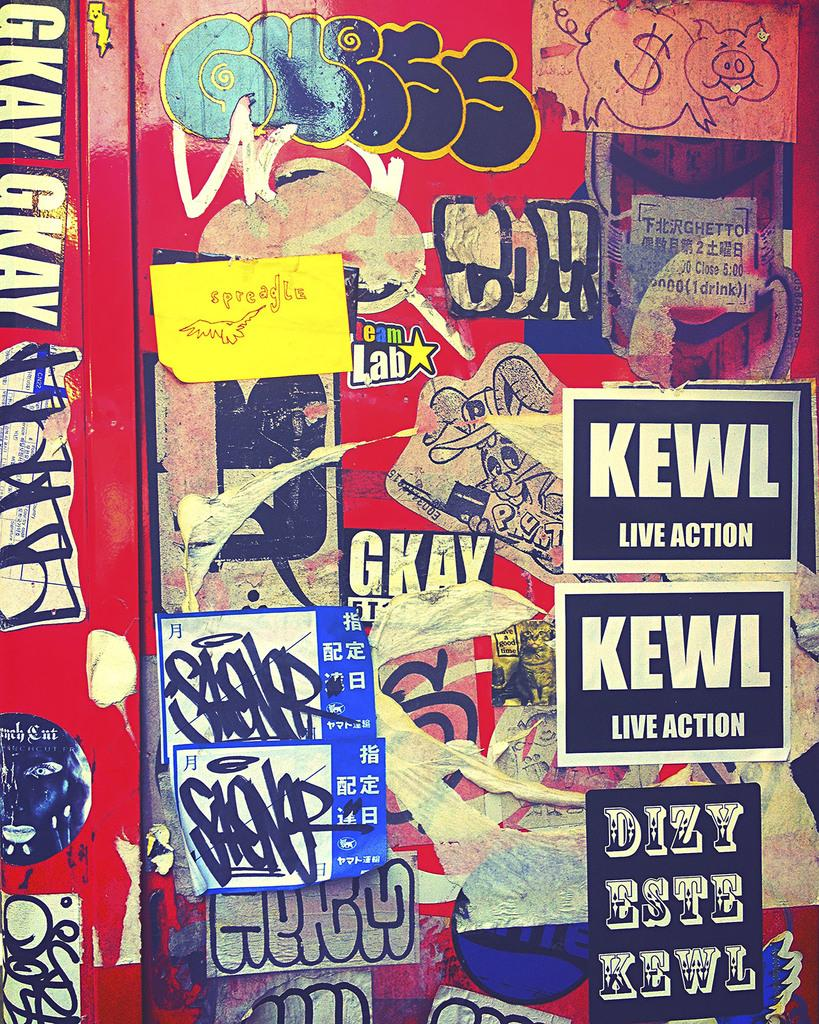<image>
Describe the image concisely. A wall with stickers that say Kewl Live Action on it. 